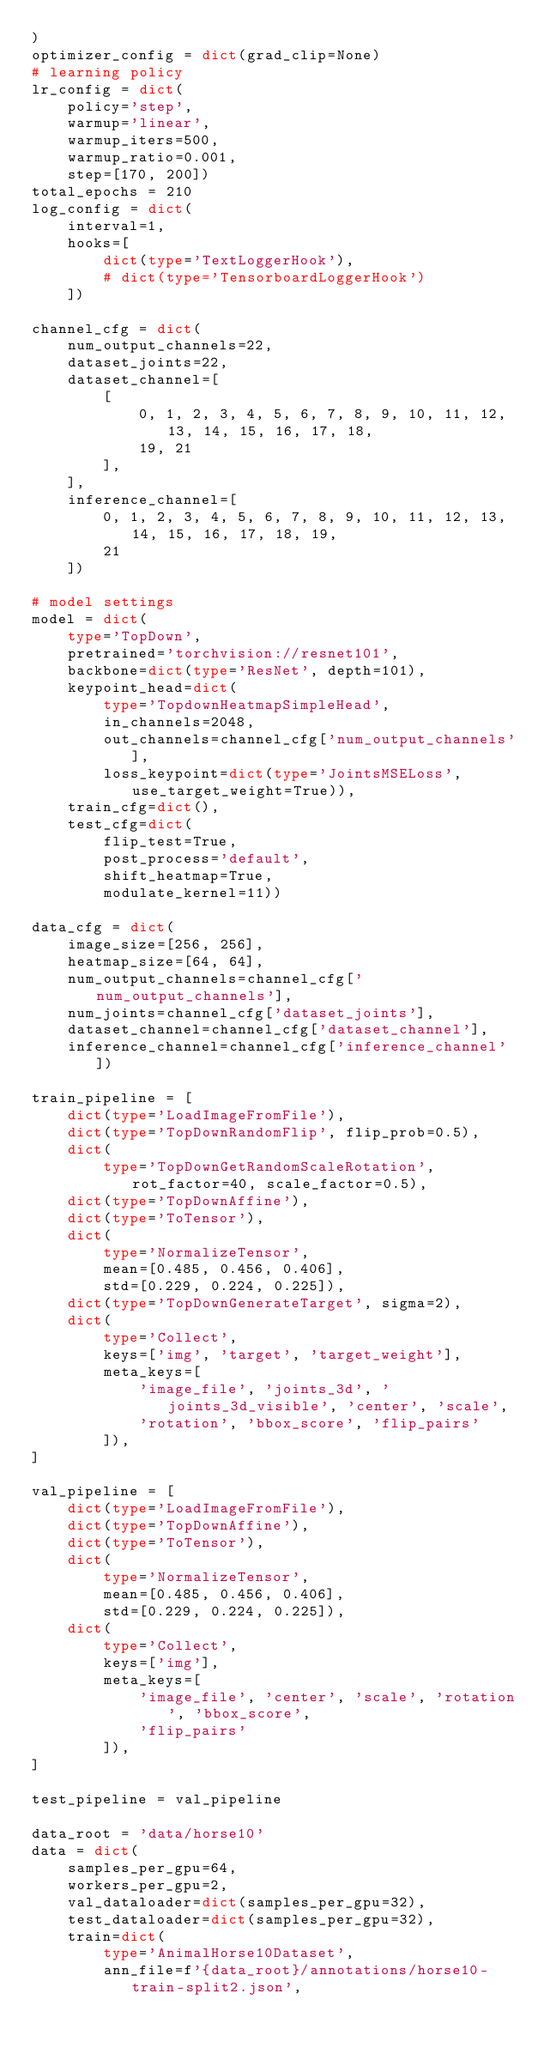<code> <loc_0><loc_0><loc_500><loc_500><_Python_>)
optimizer_config = dict(grad_clip=None)
# learning policy
lr_config = dict(
    policy='step',
    warmup='linear',
    warmup_iters=500,
    warmup_ratio=0.001,
    step=[170, 200])
total_epochs = 210
log_config = dict(
    interval=1,
    hooks=[
        dict(type='TextLoggerHook'),
        # dict(type='TensorboardLoggerHook')
    ])

channel_cfg = dict(
    num_output_channels=22,
    dataset_joints=22,
    dataset_channel=[
        [
            0, 1, 2, 3, 4, 5, 6, 7, 8, 9, 10, 11, 12, 13, 14, 15, 16, 17, 18,
            19, 21
        ],
    ],
    inference_channel=[
        0, 1, 2, 3, 4, 5, 6, 7, 8, 9, 10, 11, 12, 13, 14, 15, 16, 17, 18, 19,
        21
    ])

# model settings
model = dict(
    type='TopDown',
    pretrained='torchvision://resnet101',
    backbone=dict(type='ResNet', depth=101),
    keypoint_head=dict(
        type='TopdownHeatmapSimpleHead',
        in_channels=2048,
        out_channels=channel_cfg['num_output_channels'],
        loss_keypoint=dict(type='JointsMSELoss', use_target_weight=True)),
    train_cfg=dict(),
    test_cfg=dict(
        flip_test=True,
        post_process='default',
        shift_heatmap=True,
        modulate_kernel=11))

data_cfg = dict(
    image_size=[256, 256],
    heatmap_size=[64, 64],
    num_output_channels=channel_cfg['num_output_channels'],
    num_joints=channel_cfg['dataset_joints'],
    dataset_channel=channel_cfg['dataset_channel'],
    inference_channel=channel_cfg['inference_channel'])

train_pipeline = [
    dict(type='LoadImageFromFile'),
    dict(type='TopDownRandomFlip', flip_prob=0.5),
    dict(
        type='TopDownGetRandomScaleRotation', rot_factor=40, scale_factor=0.5),
    dict(type='TopDownAffine'),
    dict(type='ToTensor'),
    dict(
        type='NormalizeTensor',
        mean=[0.485, 0.456, 0.406],
        std=[0.229, 0.224, 0.225]),
    dict(type='TopDownGenerateTarget', sigma=2),
    dict(
        type='Collect',
        keys=['img', 'target', 'target_weight'],
        meta_keys=[
            'image_file', 'joints_3d', 'joints_3d_visible', 'center', 'scale',
            'rotation', 'bbox_score', 'flip_pairs'
        ]),
]

val_pipeline = [
    dict(type='LoadImageFromFile'),
    dict(type='TopDownAffine'),
    dict(type='ToTensor'),
    dict(
        type='NormalizeTensor',
        mean=[0.485, 0.456, 0.406],
        std=[0.229, 0.224, 0.225]),
    dict(
        type='Collect',
        keys=['img'],
        meta_keys=[
            'image_file', 'center', 'scale', 'rotation', 'bbox_score',
            'flip_pairs'
        ]),
]

test_pipeline = val_pipeline

data_root = 'data/horse10'
data = dict(
    samples_per_gpu=64,
    workers_per_gpu=2,
    val_dataloader=dict(samples_per_gpu=32),
    test_dataloader=dict(samples_per_gpu=32),
    train=dict(
        type='AnimalHorse10Dataset',
        ann_file=f'{data_root}/annotations/horse10-train-split2.json',</code> 